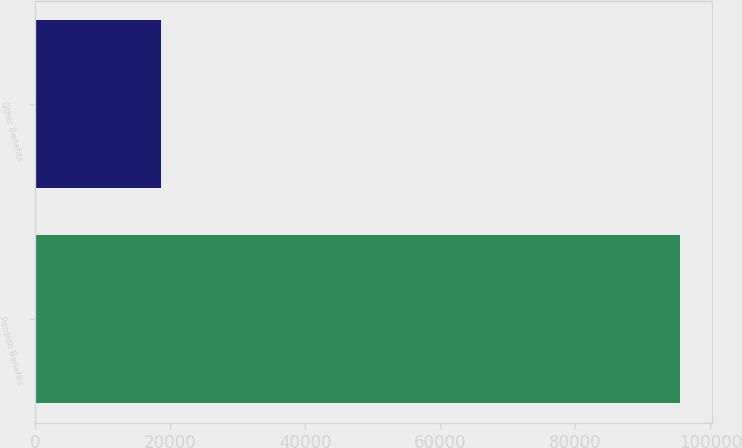Convert chart to OTSL. <chart><loc_0><loc_0><loc_500><loc_500><bar_chart><fcel>Pension Benefits<fcel>Other Benefits<nl><fcel>95461<fcel>18573<nl></chart> 